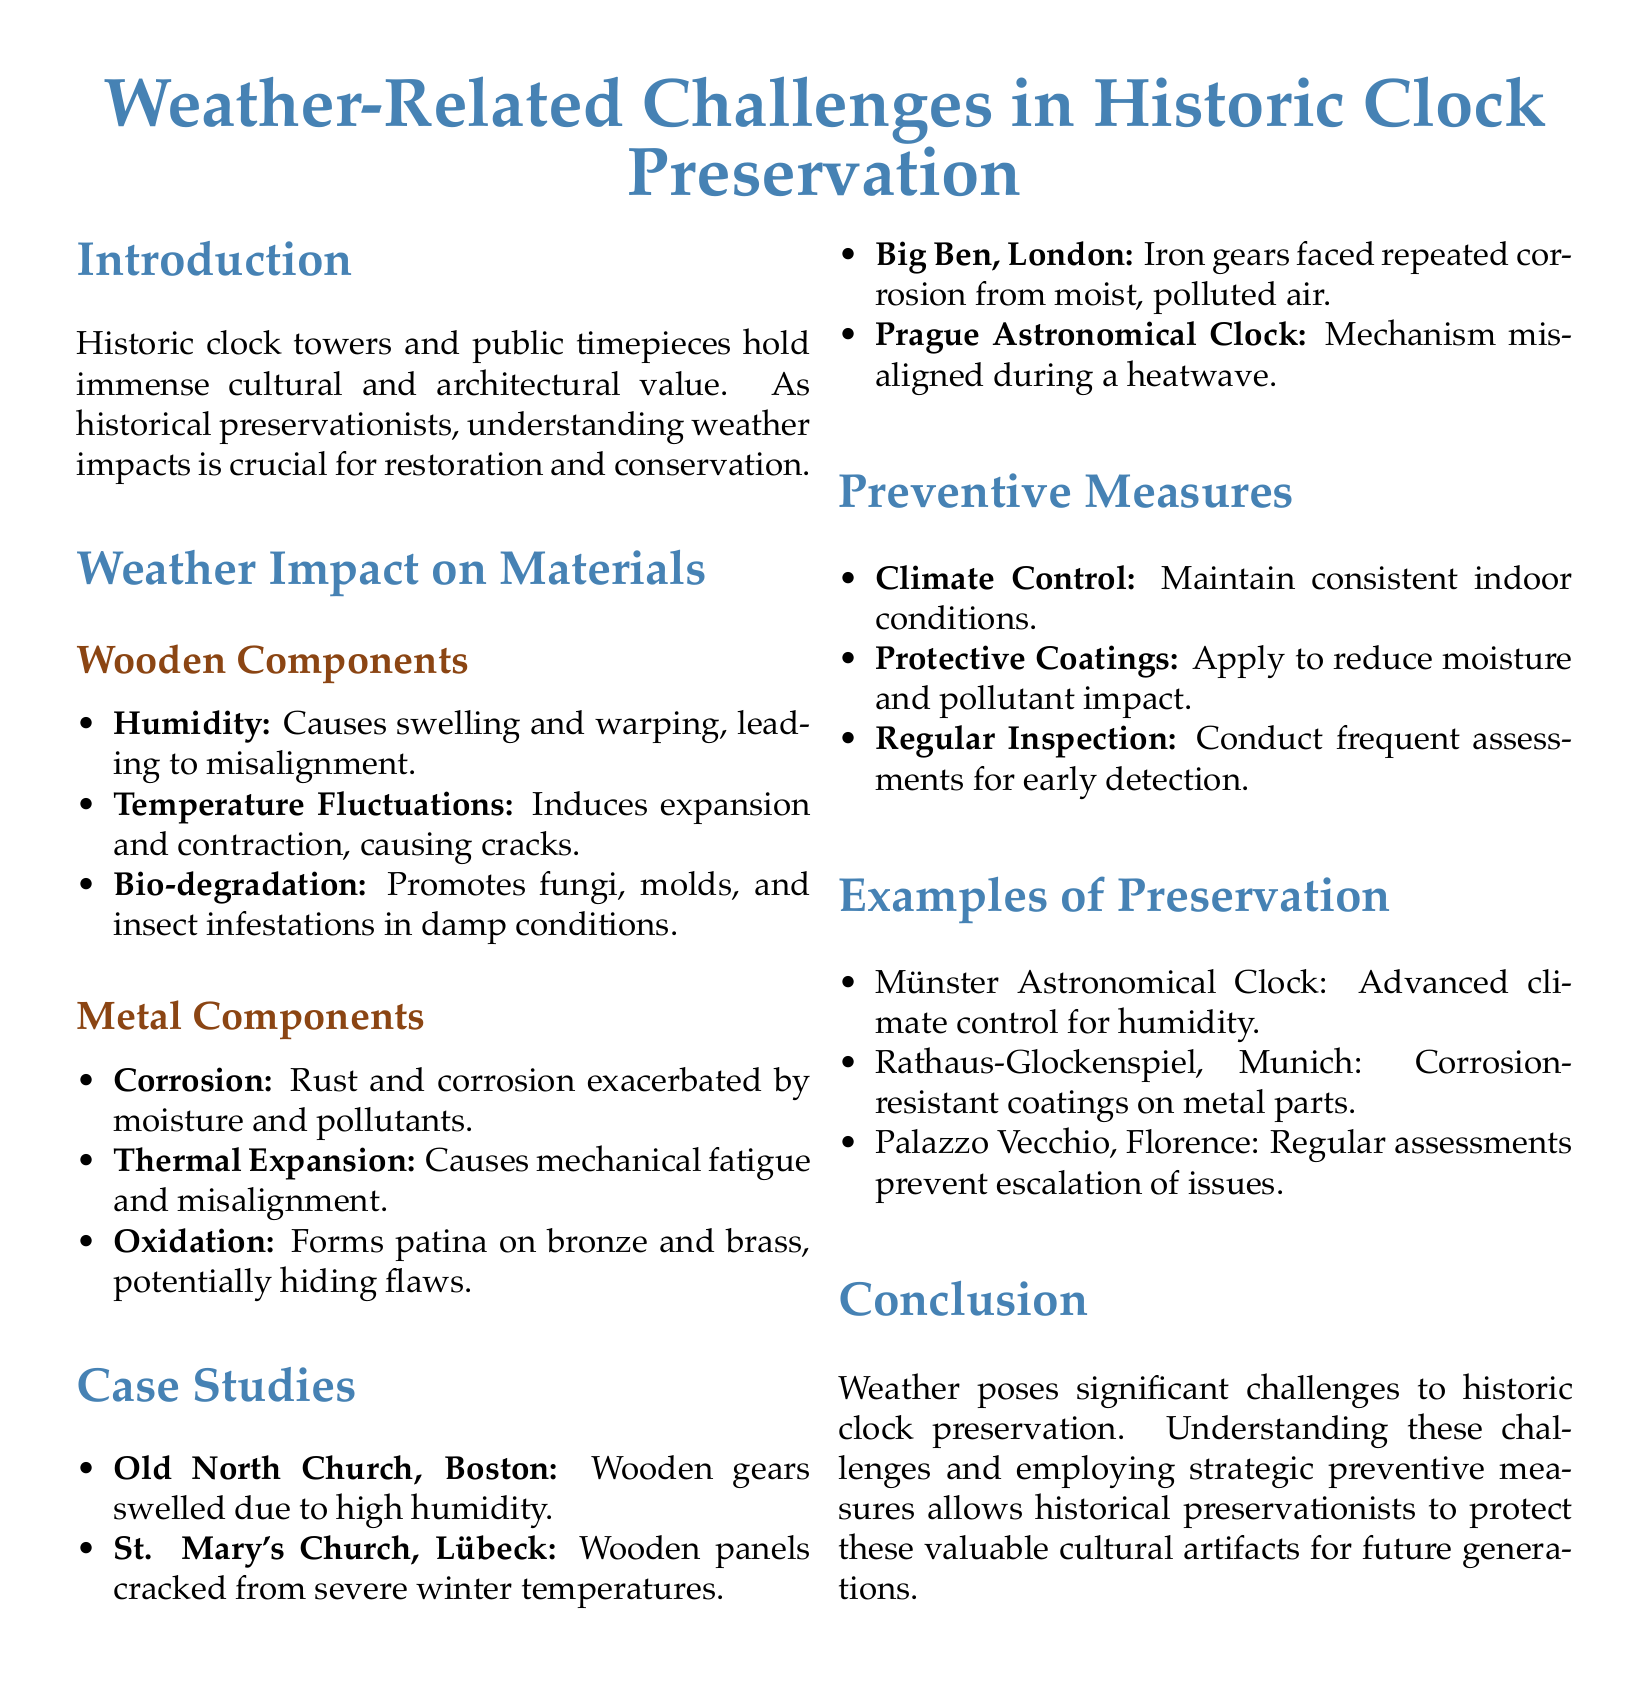What is the primary focus of the document? The document discusses the challenges posed by weather on the preservation of historic clocks.
Answer: Weather-related challenges How many case studies are mentioned? The document lists four specific case studies related to weather impacts on historic clocks.
Answer: Four What is one effect of humidity on wooden components? Humidity causes swelling and warping in wooden components of clocks.
Answer: Swelling and warping Which clock suffered from iron gear corrosion? The document specifically mentions Big Ben facing corrosion due to moist, polluted air.
Answer: Big Ben What type of coating is recommended for metal components? The document suggests applying corrosion-resistant coatings to prevent damage from moisture.
Answer: Corrosion-resistant coatings What is one preventive measure suggested for historic clocks? The document emphasizes the importance of maintaining consistent indoor conditions.
Answer: Climate control What happened to the wooden gears of the Old North Church? The document states that the wooden gears swelled due to high humidity.
Answer: Swelled due to high humidity What city is the Rathaus-Glockenspiel located in? The document mentions the Rathaus-Glockenspiel in Munich as an example of preservation measures.
Answer: Munich What is one material challenge that wooden components face? The document highlights bio-degradation as a challenge for wooden clock components.
Answer: Bio-degradation What is a beneficial practice mentioned for preservation efforts? Regular inspections are recommended in the document to ensure early detection of issues.
Answer: Regular inspection 